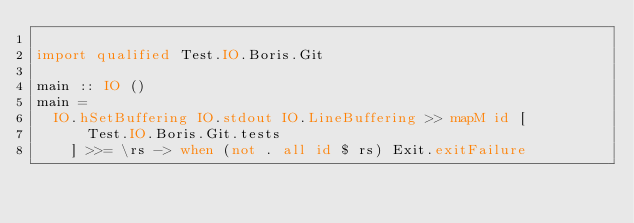Convert code to text. <code><loc_0><loc_0><loc_500><loc_500><_Haskell_>
import qualified Test.IO.Boris.Git

main :: IO ()
main =
  IO.hSetBuffering IO.stdout IO.LineBuffering >> mapM id [
      Test.IO.Boris.Git.tests
    ] >>= \rs -> when (not . all id $ rs) Exit.exitFailure
</code> 